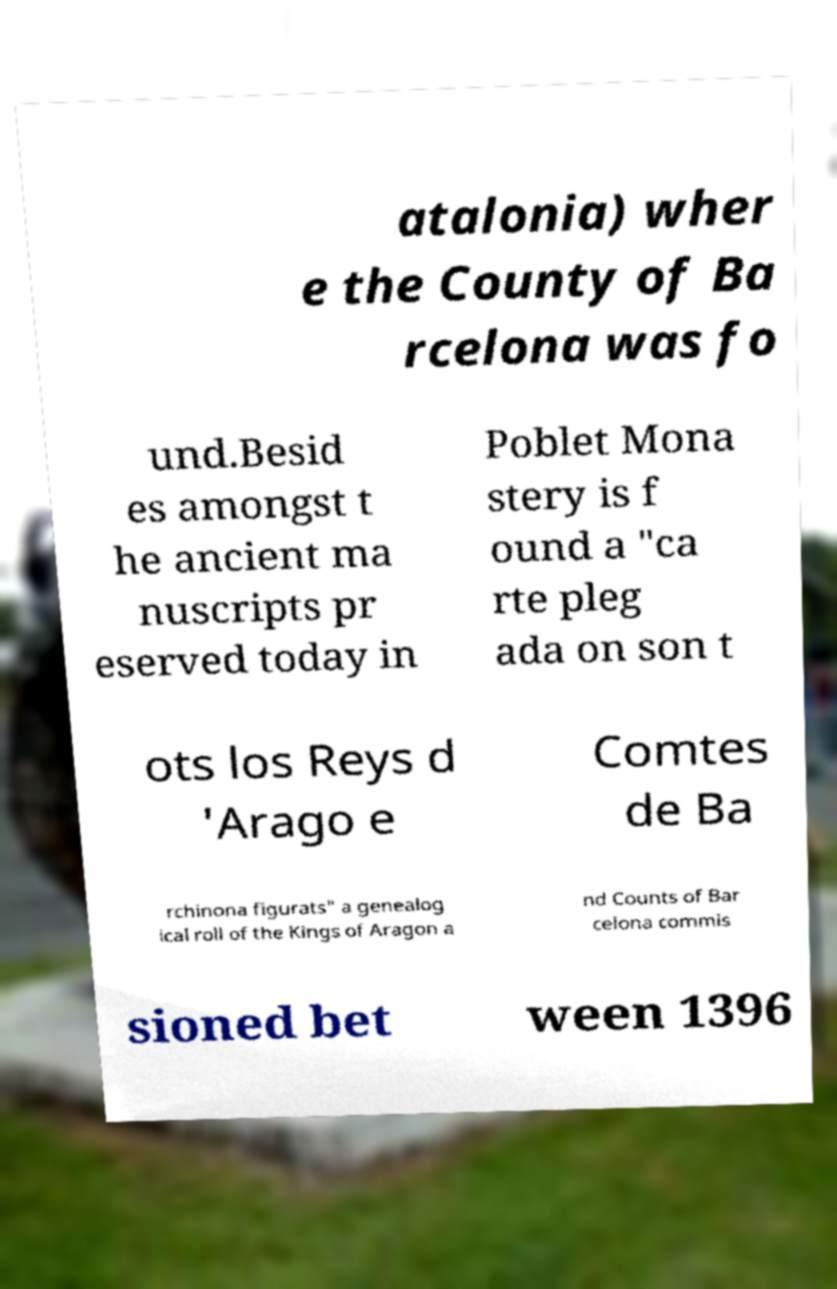For documentation purposes, I need the text within this image transcribed. Could you provide that? atalonia) wher e the County of Ba rcelona was fo und.Besid es amongst t he ancient ma nuscripts pr eserved today in Poblet Mona stery is f ound a "ca rte pleg ada on son t ots los Reys d 'Arago e Comtes de Ba rchinona figurats" a genealog ical roll of the Kings of Aragon a nd Counts of Bar celona commis sioned bet ween 1396 